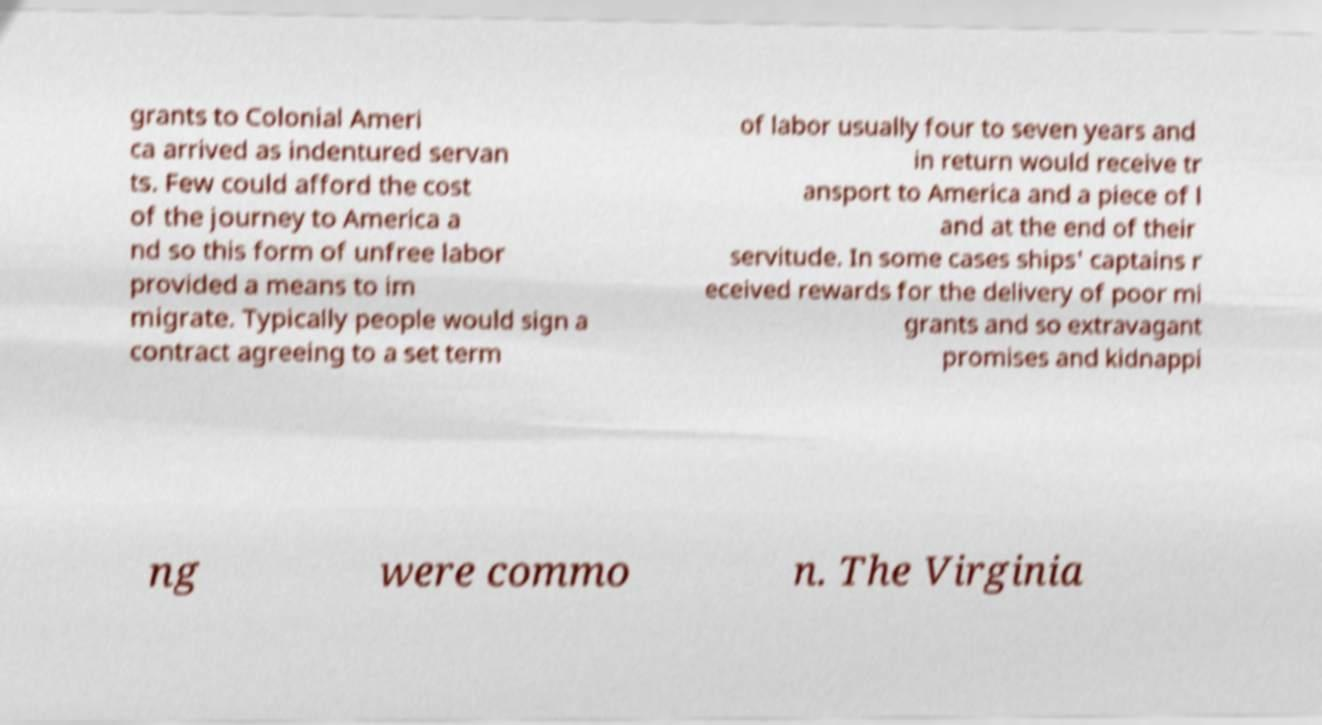Could you extract and type out the text from this image? grants to Colonial Ameri ca arrived as indentured servan ts. Few could afford the cost of the journey to America a nd so this form of unfree labor provided a means to im migrate. Typically people would sign a contract agreeing to a set term of labor usually four to seven years and in return would receive tr ansport to America and a piece of l and at the end of their servitude. In some cases ships' captains r eceived rewards for the delivery of poor mi grants and so extravagant promises and kidnappi ng were commo n. The Virginia 